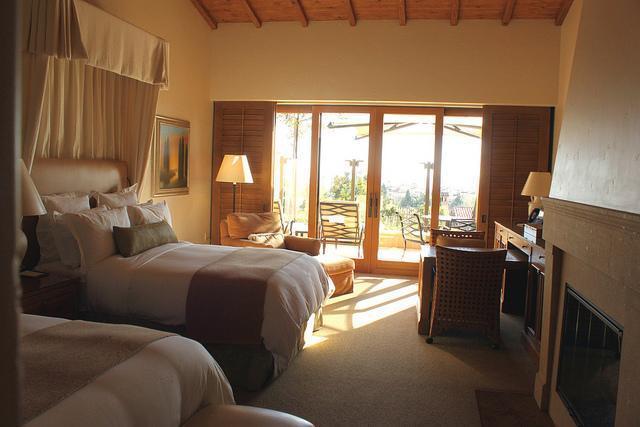How many beds are in this room?
Give a very brief answer. 2. How many picture frames are above the window?
Give a very brief answer. 0. How many pillows on the bed?
Give a very brief answer. 5. How many different color pillows are there?
Give a very brief answer. 2. How many chairs are there?
Give a very brief answer. 2. How many beds are there?
Give a very brief answer. 2. 